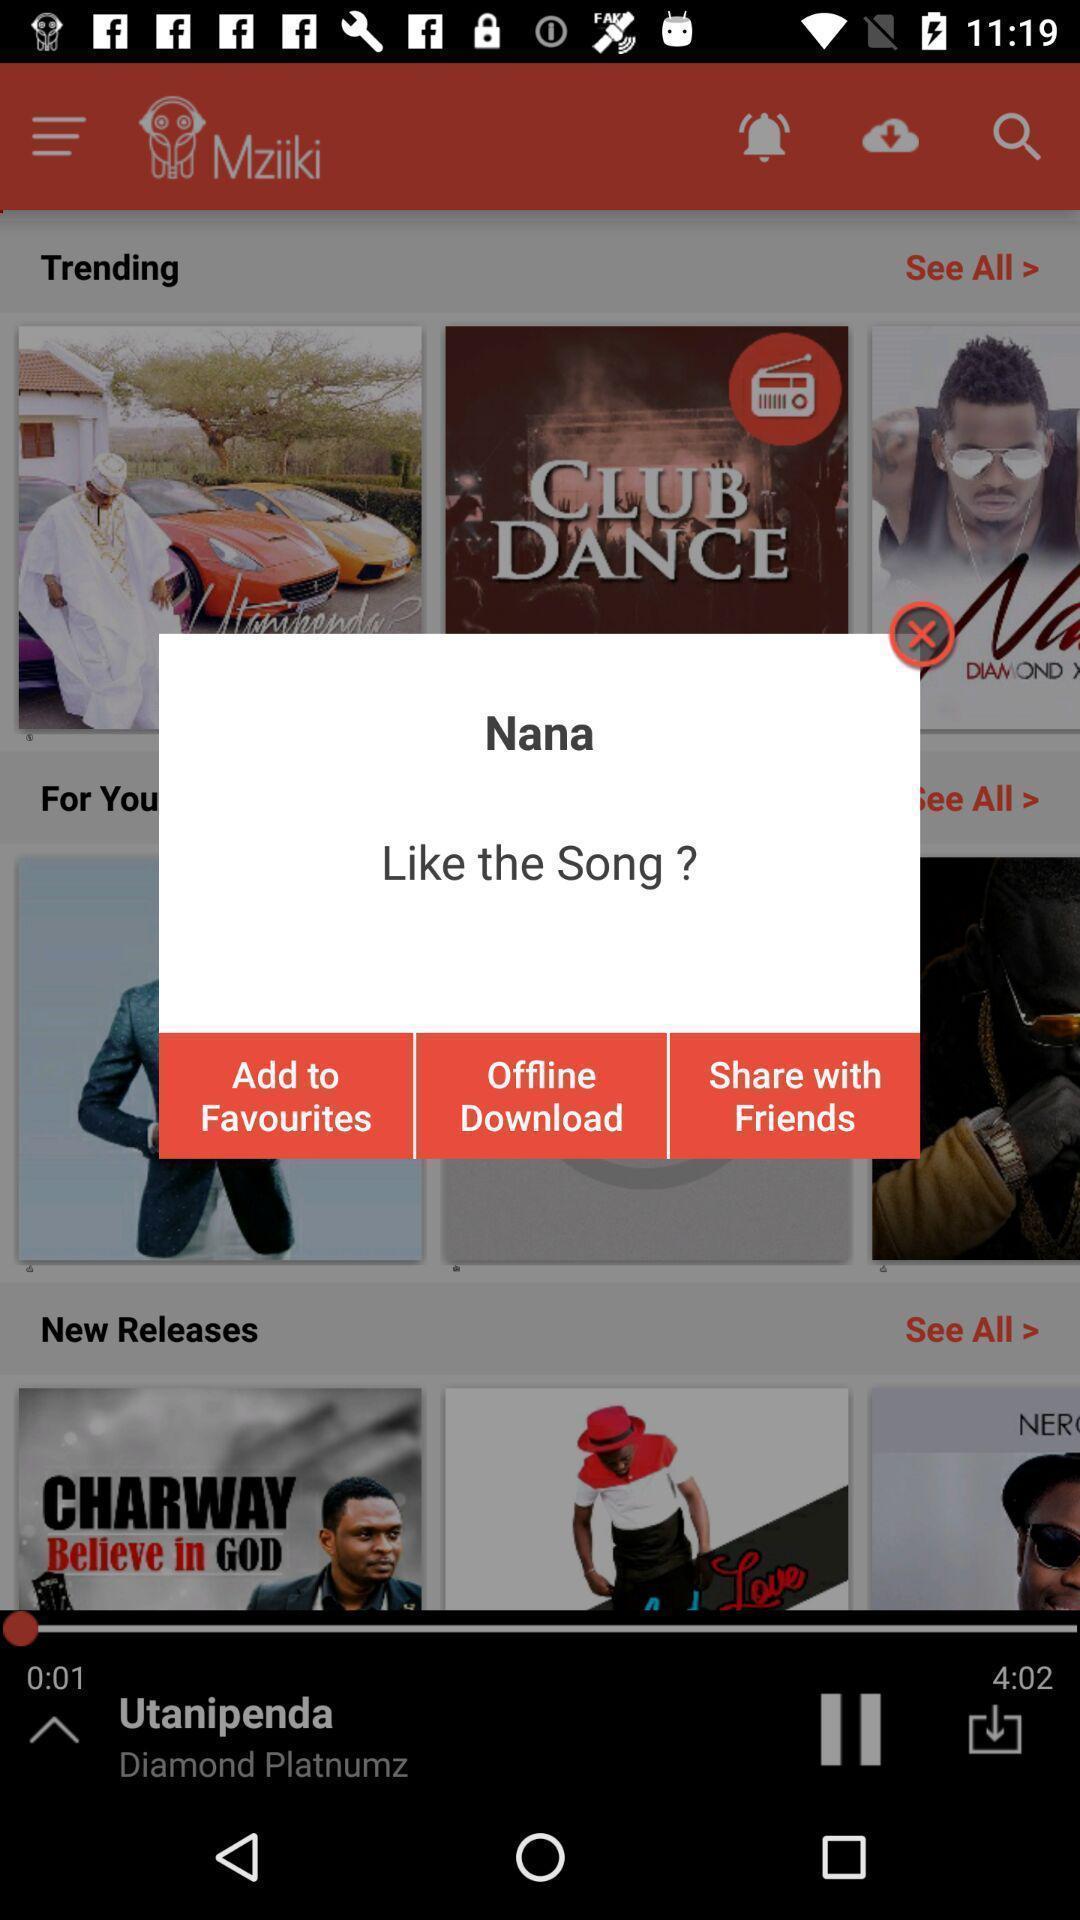Provide a textual representation of this image. Pop-up in the music streaming app. 